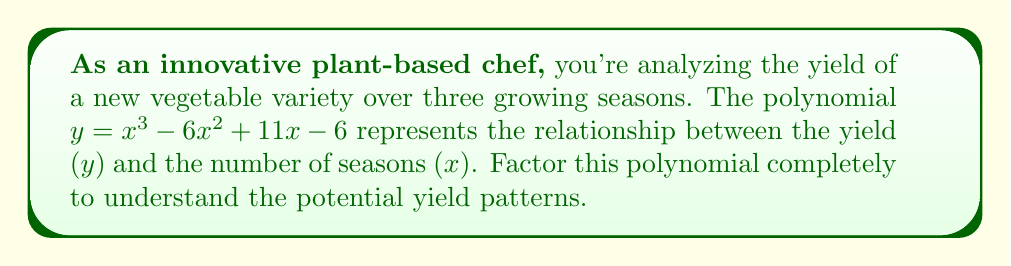Can you solve this math problem? Let's approach this step-by-step:

1) First, we'll check if there are any rational roots using the rational root theorem. The possible rational roots are the factors of the constant term: ±1, ±2, ±3, ±6.

2) Testing these values, we find that x = 1 is a root of the polynomial.

3) We can factor out (x - 1):

   $x^3 - 6x^2 + 11x - 6 = (x - 1)(x^2 - 5x + 6)$

4) Now we need to factor the quadratic term $x^2 - 5x + 6$. We can do this by finding two numbers that multiply to give 6 and add to give -5.

5) These numbers are -2 and -3.

6) So, we can factor the quadratic as:

   $x^2 - 5x + 6 = (x - 2)(x - 3)$

7) Putting it all together:

   $x^3 - 6x^2 + 11x - 6 = (x - 1)(x - 2)(x - 3)$

This factorization shows that the yield will be zero when x = 1, 2, or 3, corresponding to the end of the first, second, and third growing seasons respectively.
Answer: $y = (x - 1)(x - 2)(x - 3)$ 